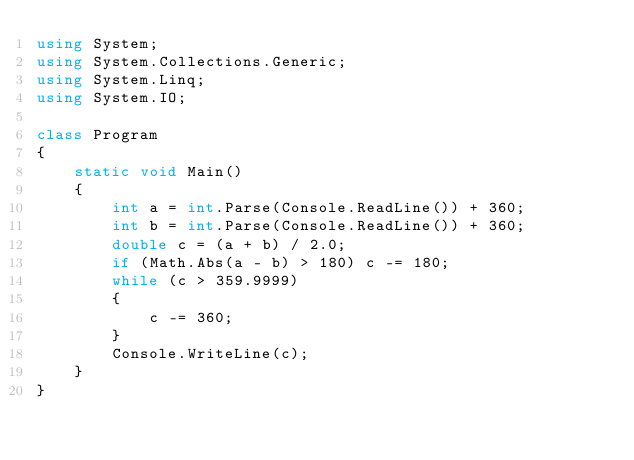Convert code to text. <code><loc_0><loc_0><loc_500><loc_500><_C#_>using System;
using System.Collections.Generic;
using System.Linq;
using System.IO;

class Program
{
    static void Main()
    {
        int a = int.Parse(Console.ReadLine()) + 360;
        int b = int.Parse(Console.ReadLine()) + 360;
        double c = (a + b) / 2.0;
        if (Math.Abs(a - b) > 180) c -= 180;
        while (c > 359.9999)
        {
            c -= 360;
        }
        Console.WriteLine(c);
    }
}</code> 